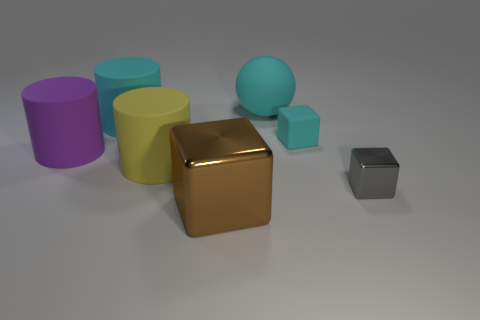Can you describe the colors and shapes of the objects in the image? Certainly! There are six objects in the image, each with a unique color and shape. Starting from the left, there's a purple cylinder, a yellow cube, a gold sphere, a cyan cylinder, a smaller turquoise cube, and a tiny silver cube. These shapes create a visually appealing array of geometric diversity and a spectrum of colors.  Which object stands out the most and why? The gold sphere stands out prominently due to its shiny, reflective surface that contrasts with the matte textures of the other objects. Its spherical shape and the way light reflects off it draw the eye immediately, distinguishing it from the other objects in the scene. 